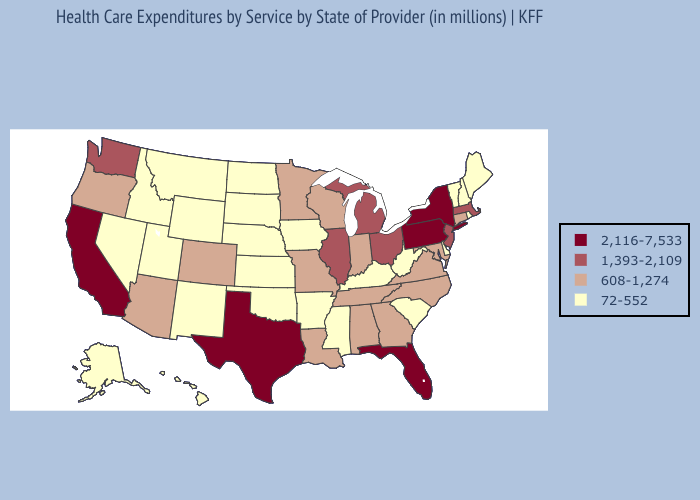Which states hav the highest value in the South?
Be succinct. Florida, Texas. Does Utah have a higher value than Georgia?
Answer briefly. No. Does West Virginia have the lowest value in the South?
Be succinct. Yes. What is the value of Ohio?
Short answer required. 1,393-2,109. How many symbols are there in the legend?
Keep it brief. 4. Does the map have missing data?
Concise answer only. No. Does Oregon have the lowest value in the USA?
Concise answer only. No. Among the states that border Vermont , does New Hampshire have the highest value?
Give a very brief answer. No. Among the states that border Mississippi , does Arkansas have the lowest value?
Concise answer only. Yes. What is the value of North Dakota?
Answer briefly. 72-552. Does Maine have the highest value in the USA?
Be succinct. No. What is the highest value in the USA?
Concise answer only. 2,116-7,533. Name the states that have a value in the range 2,116-7,533?
Give a very brief answer. California, Florida, New York, Pennsylvania, Texas. Does Missouri have the lowest value in the USA?
Answer briefly. No. Among the states that border North Carolina , which have the lowest value?
Answer briefly. South Carolina. 